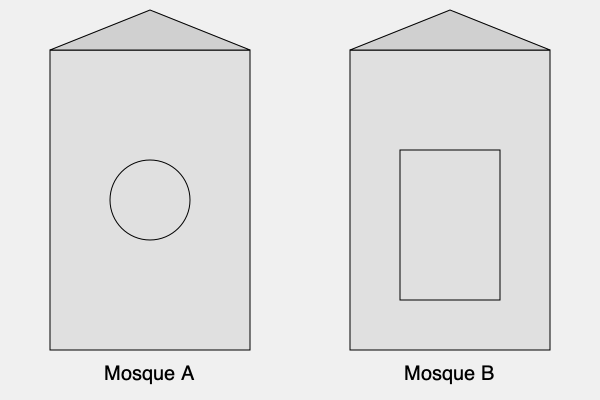Analyze the architectural features of Mosques A and B, focusing on their dome structures. Which mosque's design is more characteristic of Ottoman-style architecture, and why? To answer this question, we need to examine the key architectural features of Ottoman-style mosques and compare them to the diagrams provided:

1. Ottoman mosque characteristics:
   a. Large central dome
   b. Multiple smaller domes or semi-domes
   c. Slender minarets (not visible in these simplified diagrams)

2. Analyzing Mosque A:
   a. Has a prominent circular structure in the center, likely representing a large dome
   b. The circular shape is characteristic of Ottoman domes

3. Analyzing Mosque B:
   a. Has a rectangular structure in the center
   b. Lacks the circular dome shape typical of Ottoman architecture

4. Comparison:
   a. Mosque A's circular central structure closely resembles the large central dome of Ottoman mosques
   b. Mosque B's rectangular central structure is less typical of Ottoman architecture

5. Historical context:
   a. Ottoman architecture, developed from the 14th to 16th centuries, emphasized the central dome as a key feature
   b. The large central dome became a symbol of Ottoman imperial power and Islamic unity

6. Conclusion:
   Based on the presence of the circular dome-like structure, Mosque A is more characteristic of Ottoman-style architecture. The large central dome was a defining feature of Ottoman mosques, symbolizing the vault of heaven and emphasizing the mosque's spiritual significance.
Answer: Mosque A, due to its prominent central dome structure. 